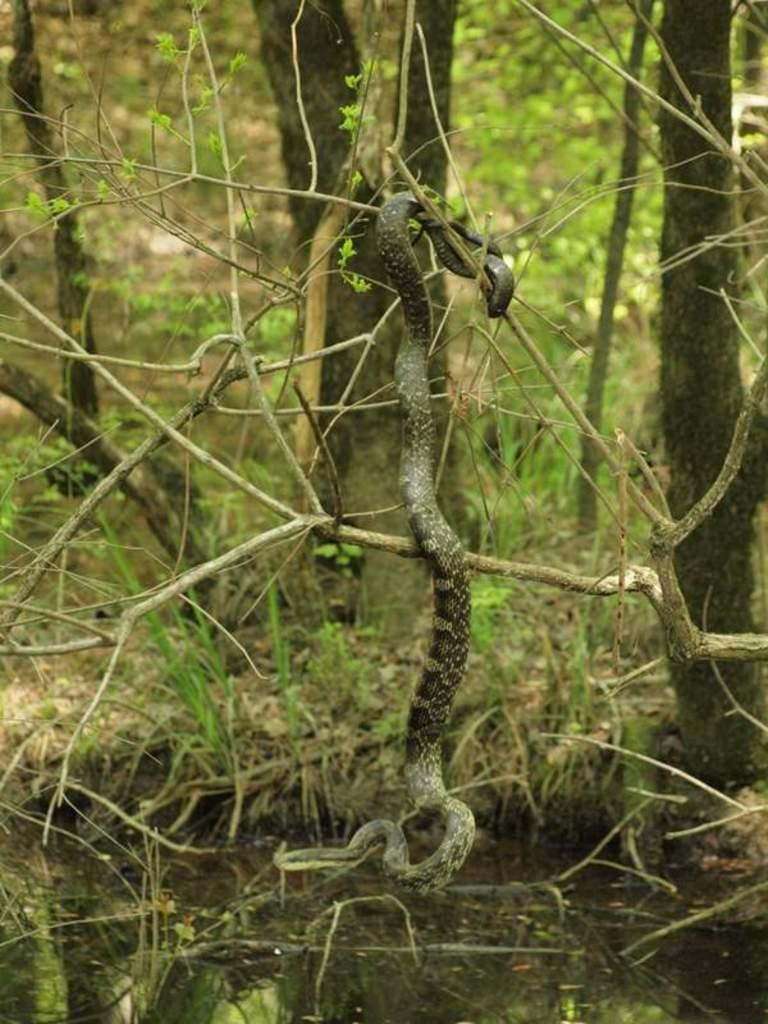What animal is present in the image? There is a snake in the image. How is the snake positioned in the image? The snake is hanging from a plant. What can be seen at the bottom of the image? There is water at the bottom of the image. What type of vegetation is visible in the background of the image? There are trees, plants, and grass in the background of the image. How does the snake feel about its size in the image? The image does not provide information about the snake's feelings or thoughts, so we cannot determine how it feels about its size. 